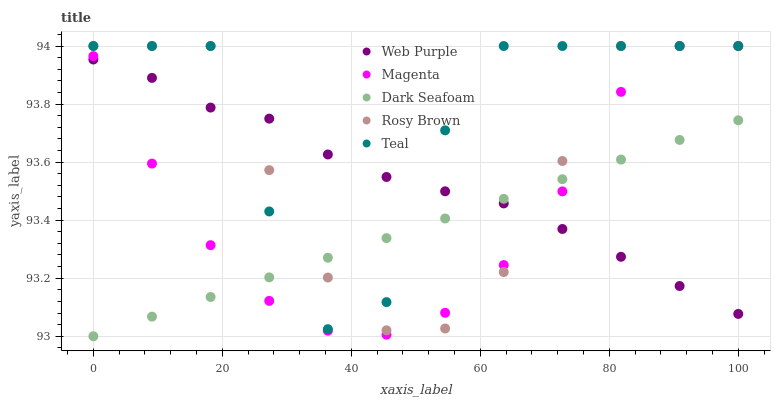Does Dark Seafoam have the minimum area under the curve?
Answer yes or no. Yes. Does Teal have the maximum area under the curve?
Answer yes or no. Yes. Does Web Purple have the minimum area under the curve?
Answer yes or no. No. Does Web Purple have the maximum area under the curve?
Answer yes or no. No. Is Dark Seafoam the smoothest?
Answer yes or no. Yes. Is Teal the roughest?
Answer yes or no. Yes. Is Web Purple the smoothest?
Answer yes or no. No. Is Web Purple the roughest?
Answer yes or no. No. Does Dark Seafoam have the lowest value?
Answer yes or no. Yes. Does Rosy Brown have the lowest value?
Answer yes or no. No. Does Magenta have the highest value?
Answer yes or no. Yes. Does Web Purple have the highest value?
Answer yes or no. No. Does Magenta intersect Dark Seafoam?
Answer yes or no. Yes. Is Magenta less than Dark Seafoam?
Answer yes or no. No. Is Magenta greater than Dark Seafoam?
Answer yes or no. No. 